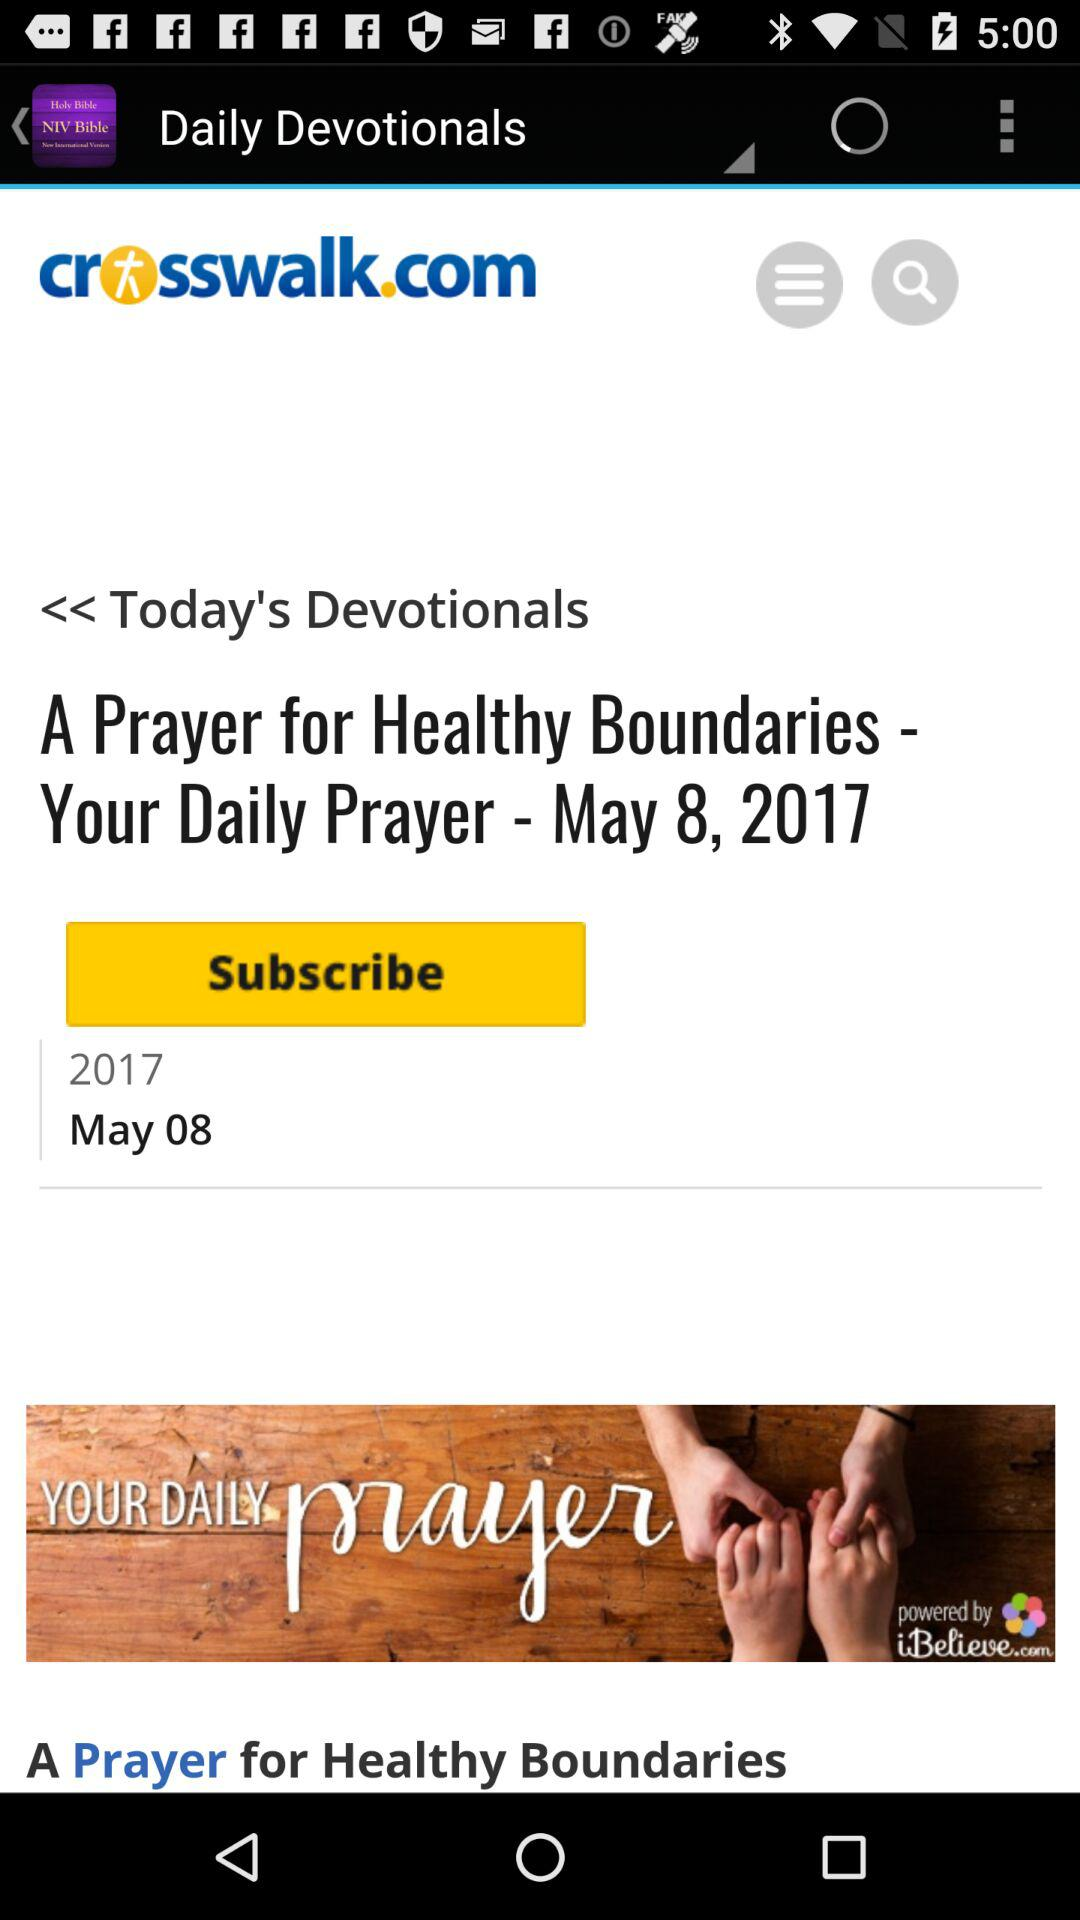What is the date? The date is May 8, 2017. 